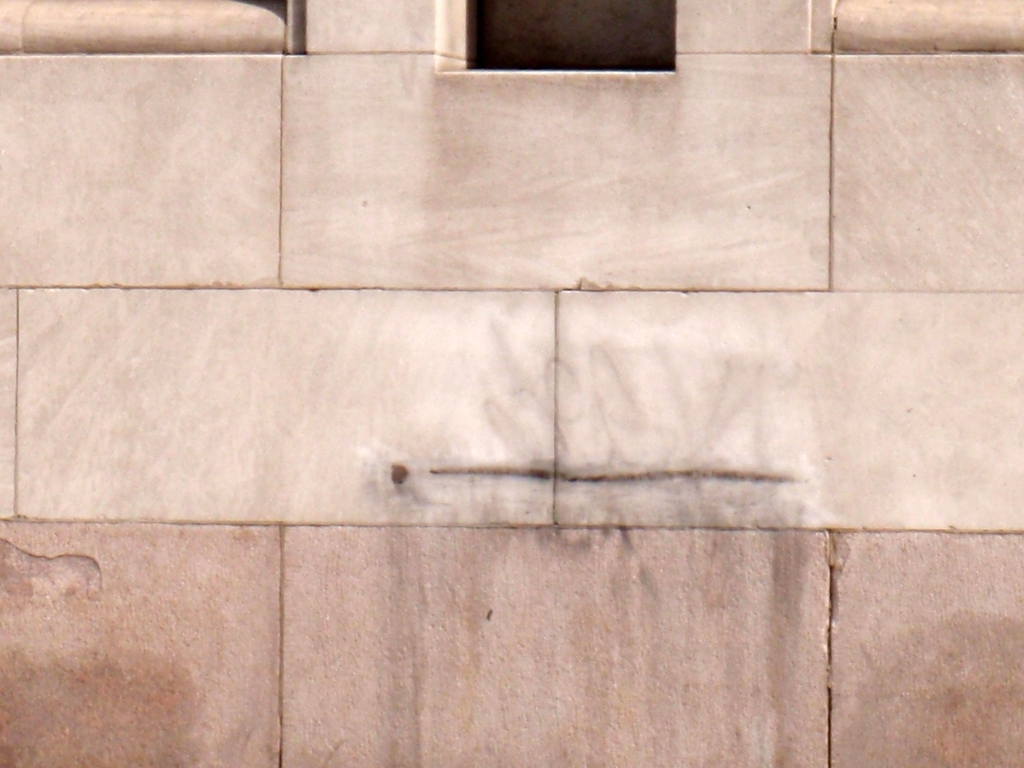Is the image crisp and detailed? The image exhibits a moderate level of detail; while the texture of the wall and faint graffiti are visible, the overall sharpness and clarity typical of a 'crisp' image is somewhat lacking. Factors such as lighting and focus might contribute to the perception that the image is not particularly crisp. 